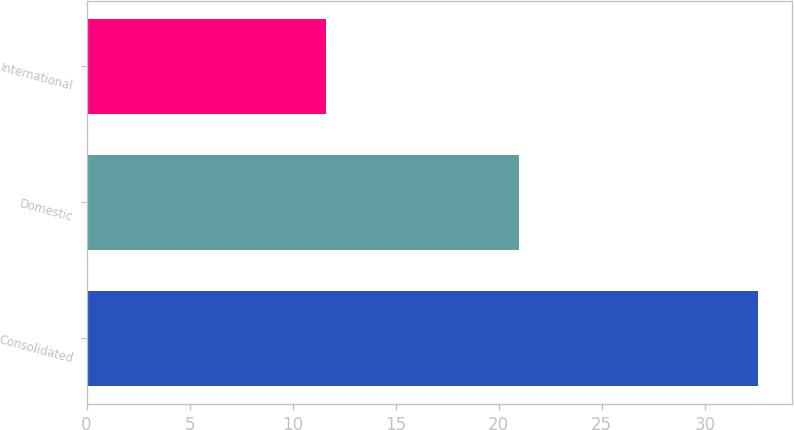Convert chart. <chart><loc_0><loc_0><loc_500><loc_500><bar_chart><fcel>Consolidated<fcel>Domestic<fcel>International<nl><fcel>32.6<fcel>21<fcel>11.6<nl></chart> 